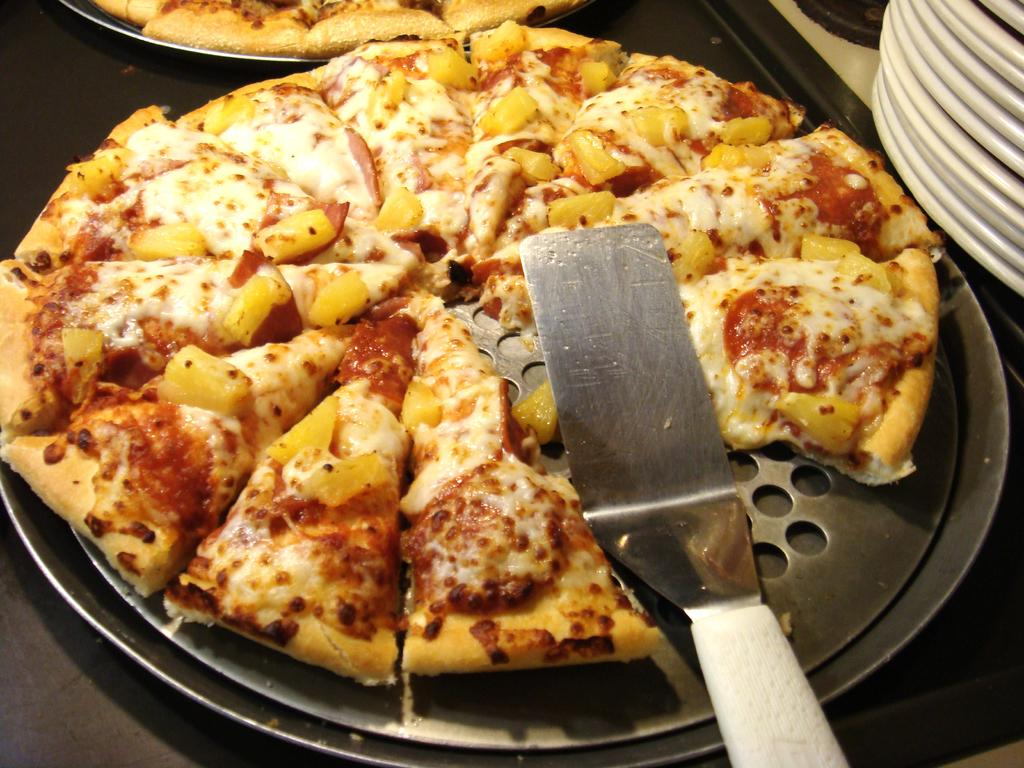What type of food is shown on the pans in the image? There are two pizzas on pans in the image. Where are the pizzas placed? The pizzas are placed on a table. What other items can be seen on the table? There are bowls visible in the image. What utensil is placed on one of the pizzas? There is a spoon on one of the pizzas. How many brothers are visible in the image? There are no brothers present in the image; it features two pizzas on pans, a table, bowls, and a spoon. 